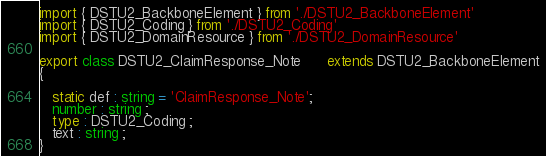Convert code to text. <code><loc_0><loc_0><loc_500><loc_500><_TypeScript_>import { DSTU2_BackboneElement } from './DSTU2_BackboneElement'
import { DSTU2_Coding } from './DSTU2_Coding'
import { DSTU2_DomainResource } from './DSTU2_DomainResource'

export class DSTU2_ClaimResponse_Note      extends DSTU2_BackboneElement
{

   static def : string = 'ClaimResponse_Note';
   number : string ;
   type : DSTU2_Coding ;
   text : string ;
}
</code> 